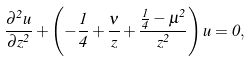<formula> <loc_0><loc_0><loc_500><loc_500>\frac { \partial ^ { 2 } u } { \partial z ^ { 2 } } + \left ( - \frac { 1 } { 4 } + \frac { \nu } { z } + \frac { \frac { 1 } { 4 } - \mu ^ { 2 } } { z ^ { 2 } } \right ) u = 0 ,</formula> 